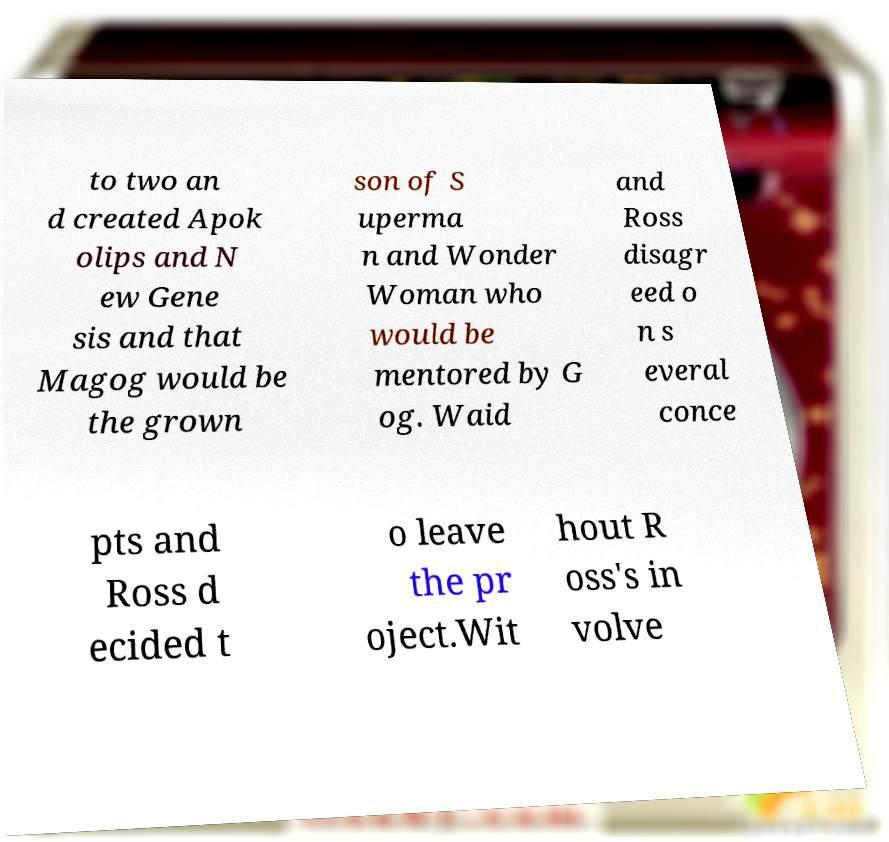Could you assist in decoding the text presented in this image and type it out clearly? to two an d created Apok olips and N ew Gene sis and that Magog would be the grown son of S uperma n and Wonder Woman who would be mentored by G og. Waid and Ross disagr eed o n s everal conce pts and Ross d ecided t o leave the pr oject.Wit hout R oss's in volve 